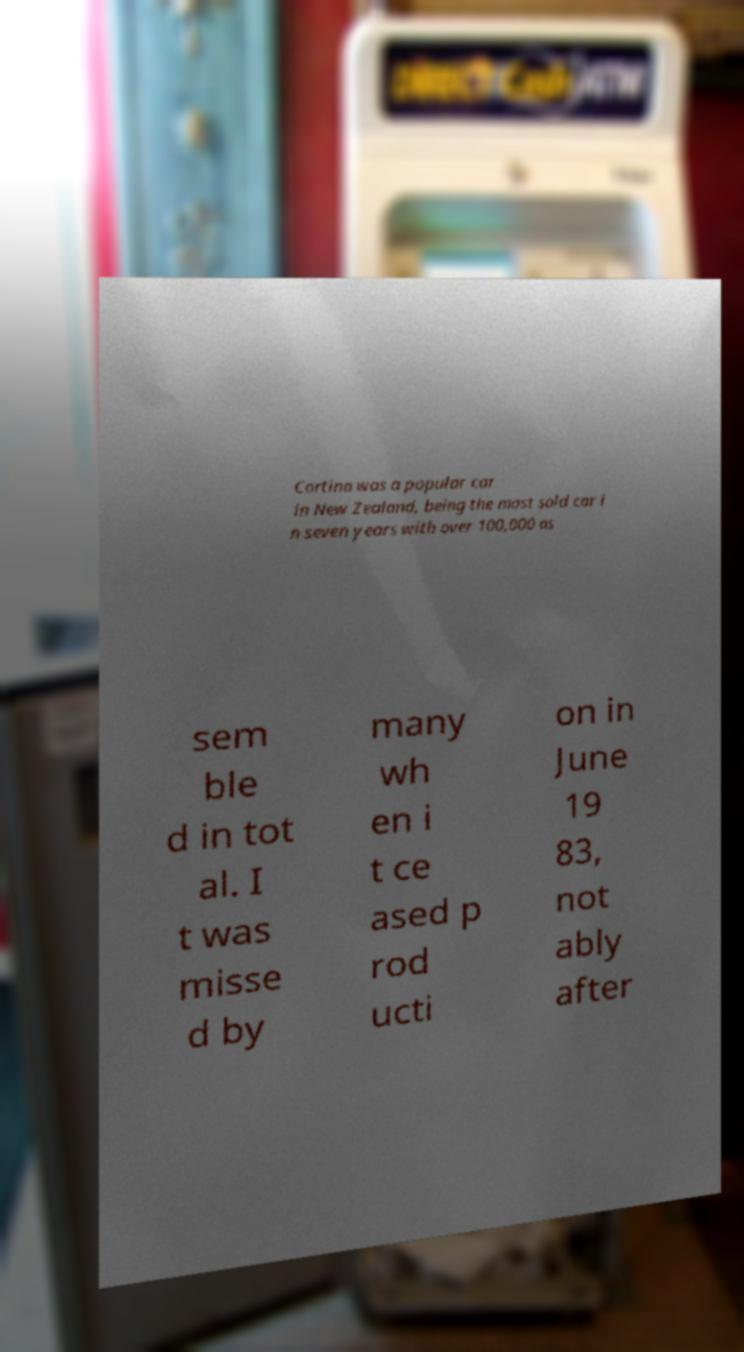Please identify and transcribe the text found in this image. Cortina was a popular car in New Zealand, being the most sold car i n seven years with over 100,000 as sem ble d in tot al. I t was misse d by many wh en i t ce ased p rod ucti on in June 19 83, not ably after 